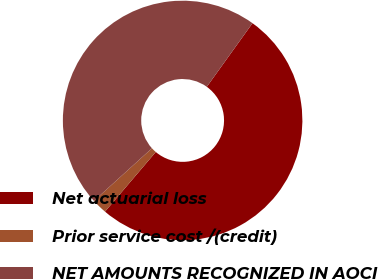Convert chart to OTSL. <chart><loc_0><loc_0><loc_500><loc_500><pie_chart><fcel>Net actuarial loss<fcel>Prior service cost /(credit)<fcel>NET AMOUNTS RECOGNIZED IN AOCI<nl><fcel>51.31%<fcel>2.05%<fcel>46.64%<nl></chart> 